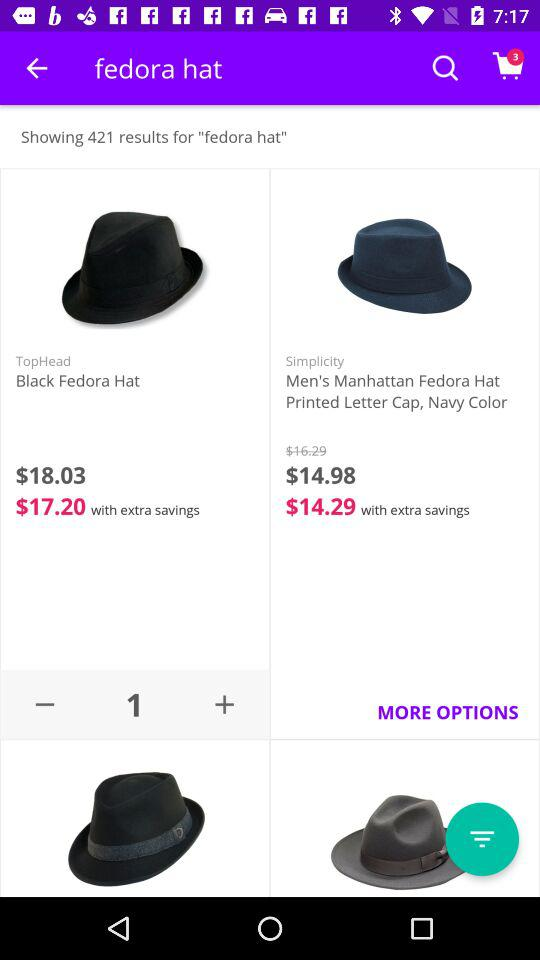What is the discounted price of the "Men's Manhattan Fedora Hat"? The discounted price of the "Men's Manhattan Fedora Hat" is $14.98. 